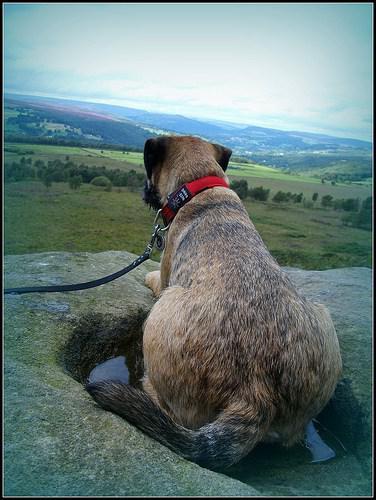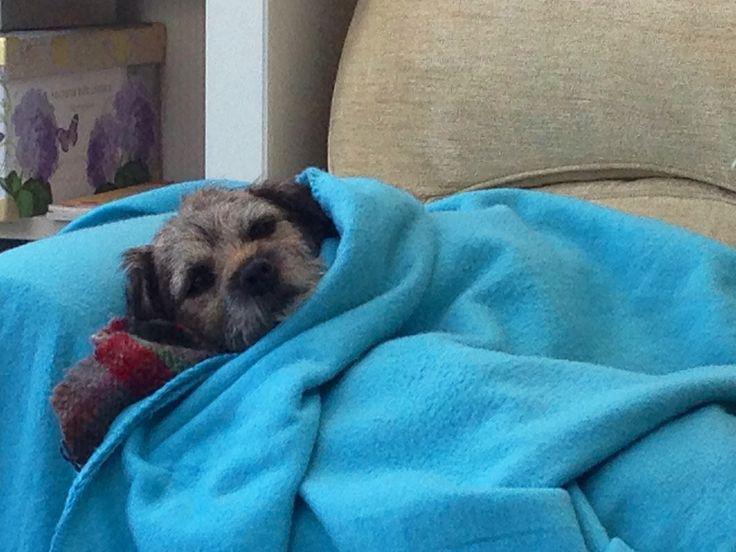The first image is the image on the left, the second image is the image on the right. Given the left and right images, does the statement "There is a Border Terrier standing inside in the right image." hold true? Answer yes or no. No. The first image is the image on the left, the second image is the image on the right. Assess this claim about the two images: "There is a single dog with it's tongue slightly visible in the right image.". Correct or not? Answer yes or no. No. 